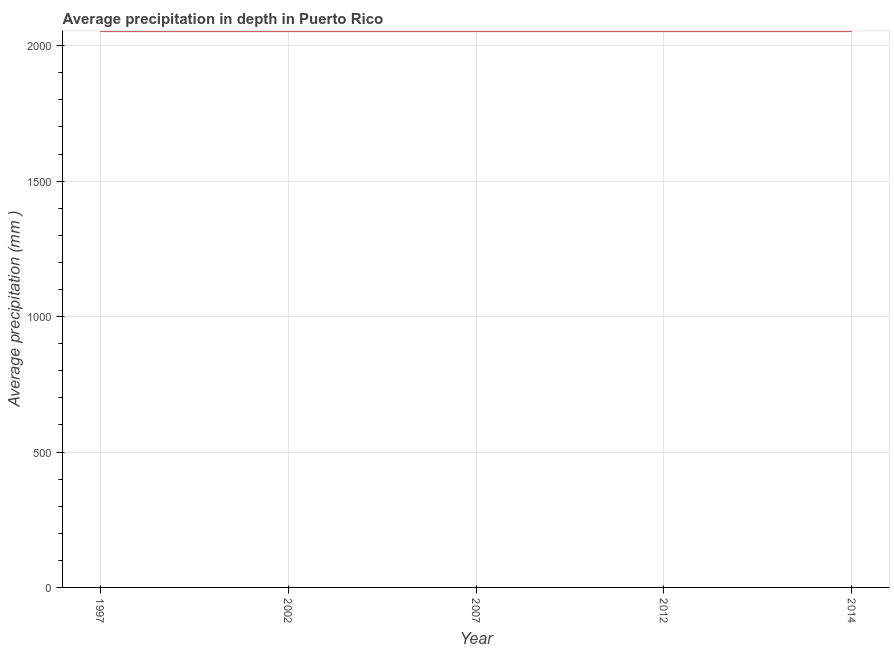What is the average precipitation in depth in 2002?
Offer a terse response. 2054. Across all years, what is the maximum average precipitation in depth?
Ensure brevity in your answer.  2054. Across all years, what is the minimum average precipitation in depth?
Ensure brevity in your answer.  2054. In which year was the average precipitation in depth maximum?
Your response must be concise. 1997. In which year was the average precipitation in depth minimum?
Offer a very short reply. 1997. What is the sum of the average precipitation in depth?
Your answer should be compact. 1.03e+04. What is the difference between the average precipitation in depth in 1997 and 2012?
Offer a terse response. 0. What is the average average precipitation in depth per year?
Give a very brief answer. 2054. What is the median average precipitation in depth?
Keep it short and to the point. 2054. In how many years, is the average precipitation in depth greater than 800 mm?
Your answer should be compact. 5. Do a majority of the years between 1997 and 2002 (inclusive) have average precipitation in depth greater than 1600 mm?
Your answer should be compact. Yes. Does the average precipitation in depth monotonically increase over the years?
Make the answer very short. No. How many lines are there?
Make the answer very short. 1. What is the difference between two consecutive major ticks on the Y-axis?
Ensure brevity in your answer.  500. Does the graph contain any zero values?
Keep it short and to the point. No. Does the graph contain grids?
Offer a very short reply. Yes. What is the title of the graph?
Your response must be concise. Average precipitation in depth in Puerto Rico. What is the label or title of the Y-axis?
Make the answer very short. Average precipitation (mm ). What is the Average precipitation (mm ) of 1997?
Your response must be concise. 2054. What is the Average precipitation (mm ) in 2002?
Your answer should be compact. 2054. What is the Average precipitation (mm ) of 2007?
Provide a short and direct response. 2054. What is the Average precipitation (mm ) in 2012?
Offer a terse response. 2054. What is the Average precipitation (mm ) in 2014?
Provide a succinct answer. 2054. What is the difference between the Average precipitation (mm ) in 1997 and 2002?
Provide a succinct answer. 0. What is the difference between the Average precipitation (mm ) in 1997 and 2012?
Make the answer very short. 0. What is the difference between the Average precipitation (mm ) in 1997 and 2014?
Ensure brevity in your answer.  0. What is the difference between the Average precipitation (mm ) in 2002 and 2007?
Your answer should be compact. 0. What is the difference between the Average precipitation (mm ) in 2007 and 2014?
Offer a terse response. 0. What is the ratio of the Average precipitation (mm ) in 1997 to that in 2002?
Provide a short and direct response. 1. What is the ratio of the Average precipitation (mm ) in 1997 to that in 2007?
Ensure brevity in your answer.  1. What is the ratio of the Average precipitation (mm ) in 1997 to that in 2014?
Provide a succinct answer. 1. What is the ratio of the Average precipitation (mm ) in 2002 to that in 2012?
Your response must be concise. 1. 